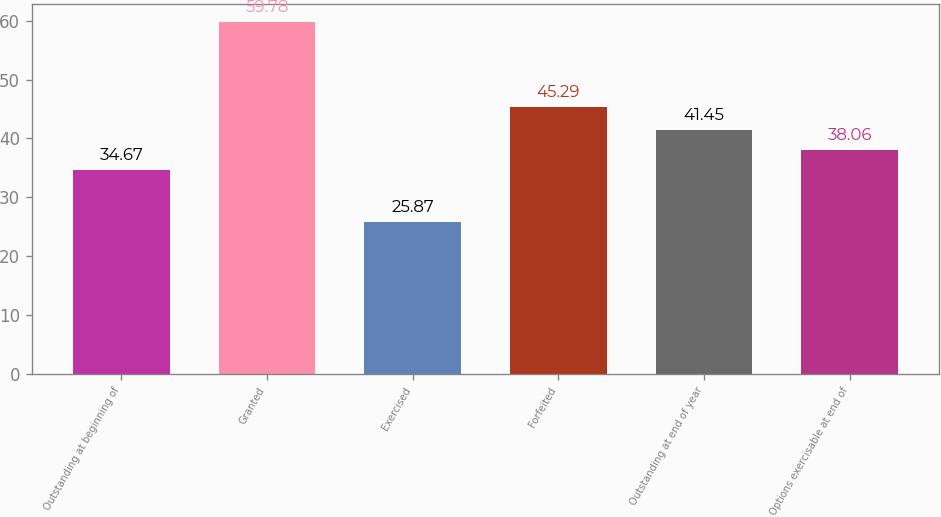Convert chart to OTSL. <chart><loc_0><loc_0><loc_500><loc_500><bar_chart><fcel>Outstanding at beginning of<fcel>Granted<fcel>Exercised<fcel>Forfeited<fcel>Outstanding at end of year<fcel>Options exercisable at end of<nl><fcel>34.67<fcel>59.78<fcel>25.87<fcel>45.29<fcel>41.45<fcel>38.06<nl></chart> 